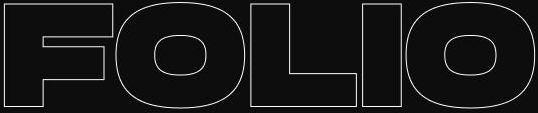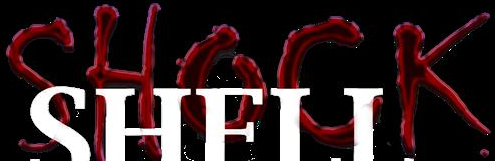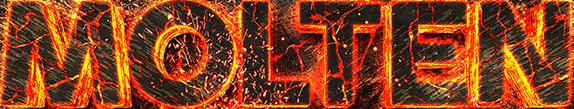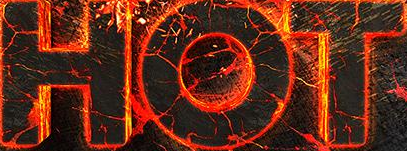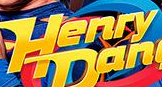What words can you see in these images in sequence, separated by a semicolon? FOLIO; SHOCK; MOLTEN; HOT; Henry 